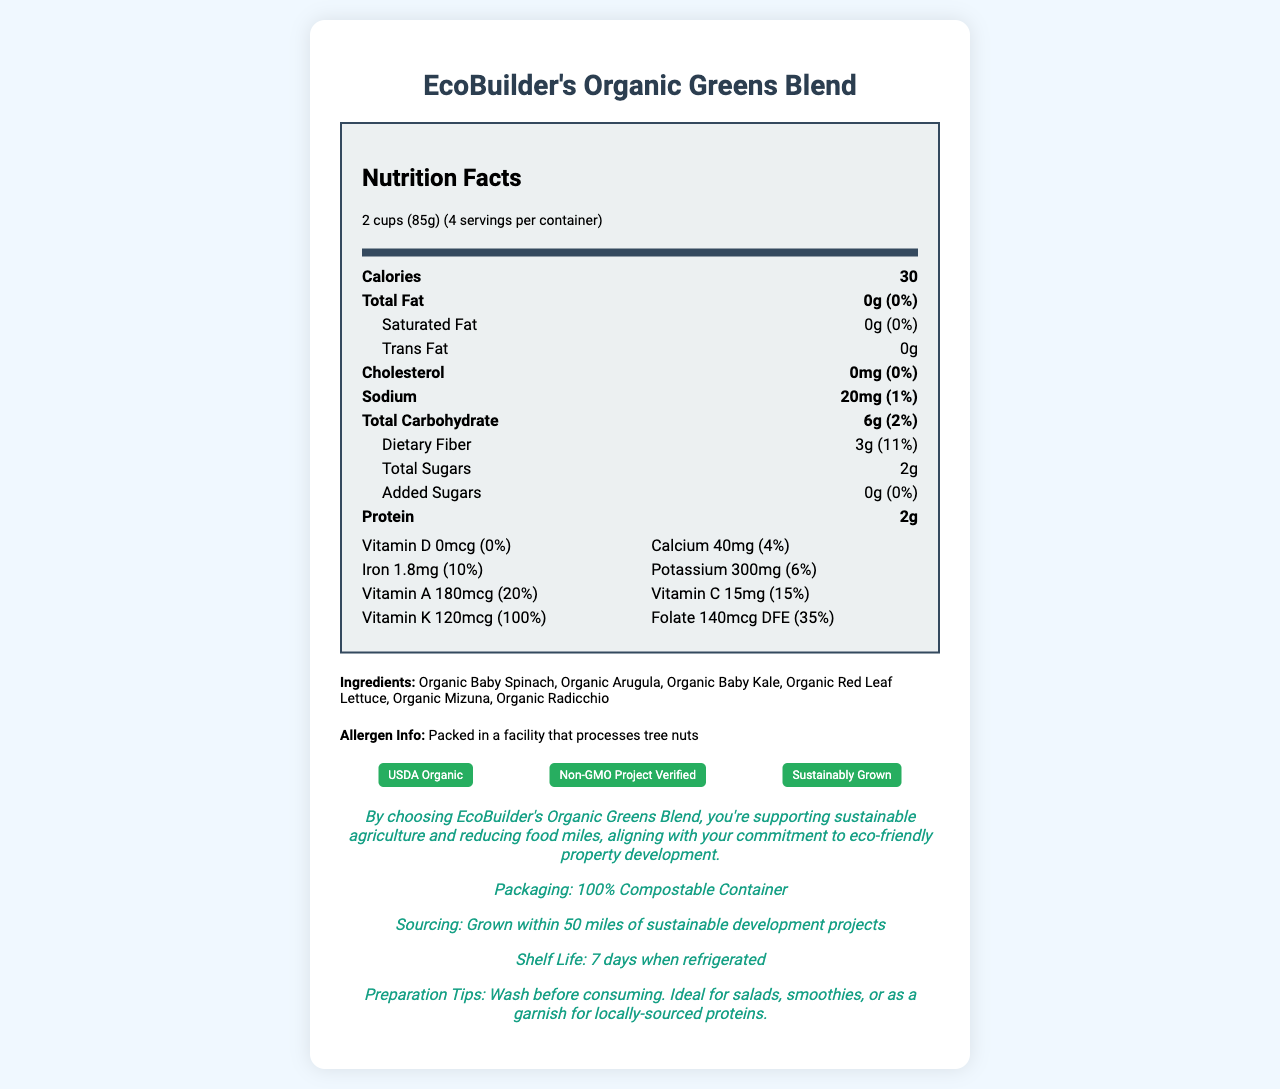who can benefit from choosing EcoBuilder's Organic Greens Blend? The sustainability message indicates that by choosing EcoBuilder's Organic Greens Blend, you're supporting sustainable agriculture and reducing food miles, aligning with your commitment to eco-friendly property development.
Answer: Eco-conscious property developers how many servings are there in one container of EcoBuilder's Organic Greens Blend? The serving information states there are 4 servings per container.
Answer: 4 what is the serving size for EcoBuilder's Organic Greens Blend? The serving size is specified as 2 cups (85g) in the document.
Answer: 2 cups (85g) how much dietary fiber does one serving of EcoBuilder's Organic Greens Blend contain? The dietary fiber content per serving is listed as 3g in the nutrition label.
Answer: 3g list the organic ingredients found in EcoBuilder's Organic Greens Blend? The ingredients section lists all these organic components.
Answer: Organic Baby Spinach, Organic Arugula, Organic Baby Kale, Organic Red Leaf Lettuce, Organic Mizuna, Organic Radicchio which certification is NOT held by EcoBuilder's Organic Greens Blend? A. USDA Organic B. Fair Trade Certified C. Non-GMO Project Verified D. Sustainably Grown The document lists USDA Organic, Non-GMO Project Verified, and Sustainably Grown as certifications, but Fair Trade Certified is not mentioned.
Answer: B. Fair Trade Certified how much vitamin K does one serving provide? A. 20% B. 35% C. 100% D. 50% The nutrition label shows that one serving provides 120mcg of Vitamin K, which is 100% of the daily value.
Answer: C. 100% does EcoBuilder's Organic Greens Blend contain any added sugars? The label indicates that there are 0g of added sugars per serving.
Answer: No is the sodium level in EcoBuilder's Organic Greens Blend high? The sodium amount is 20mg per serving, which is only 1% of the daily value, indicating a low sodium level.
Answer: No summarize the main idea of the document. The document highlights the nutritional content of the product, lists its ingredients, mentions allergen information, certifications, eco-friendly packaging, and includes a sustainability message directed at eco-conscious property developers.
Answer: The document provides detailed nutritional information, ingredients, allergen info, certifications, and eco-friendly credentials for EcoBuilder's Organic Greens Blend, emphasizing its organic nature, local sourcing, and sustainability benefits. is there information about the carbon footprint of the product? The document does not provide specific information about the carbon footprint of the product.
Answer: Not enough information 